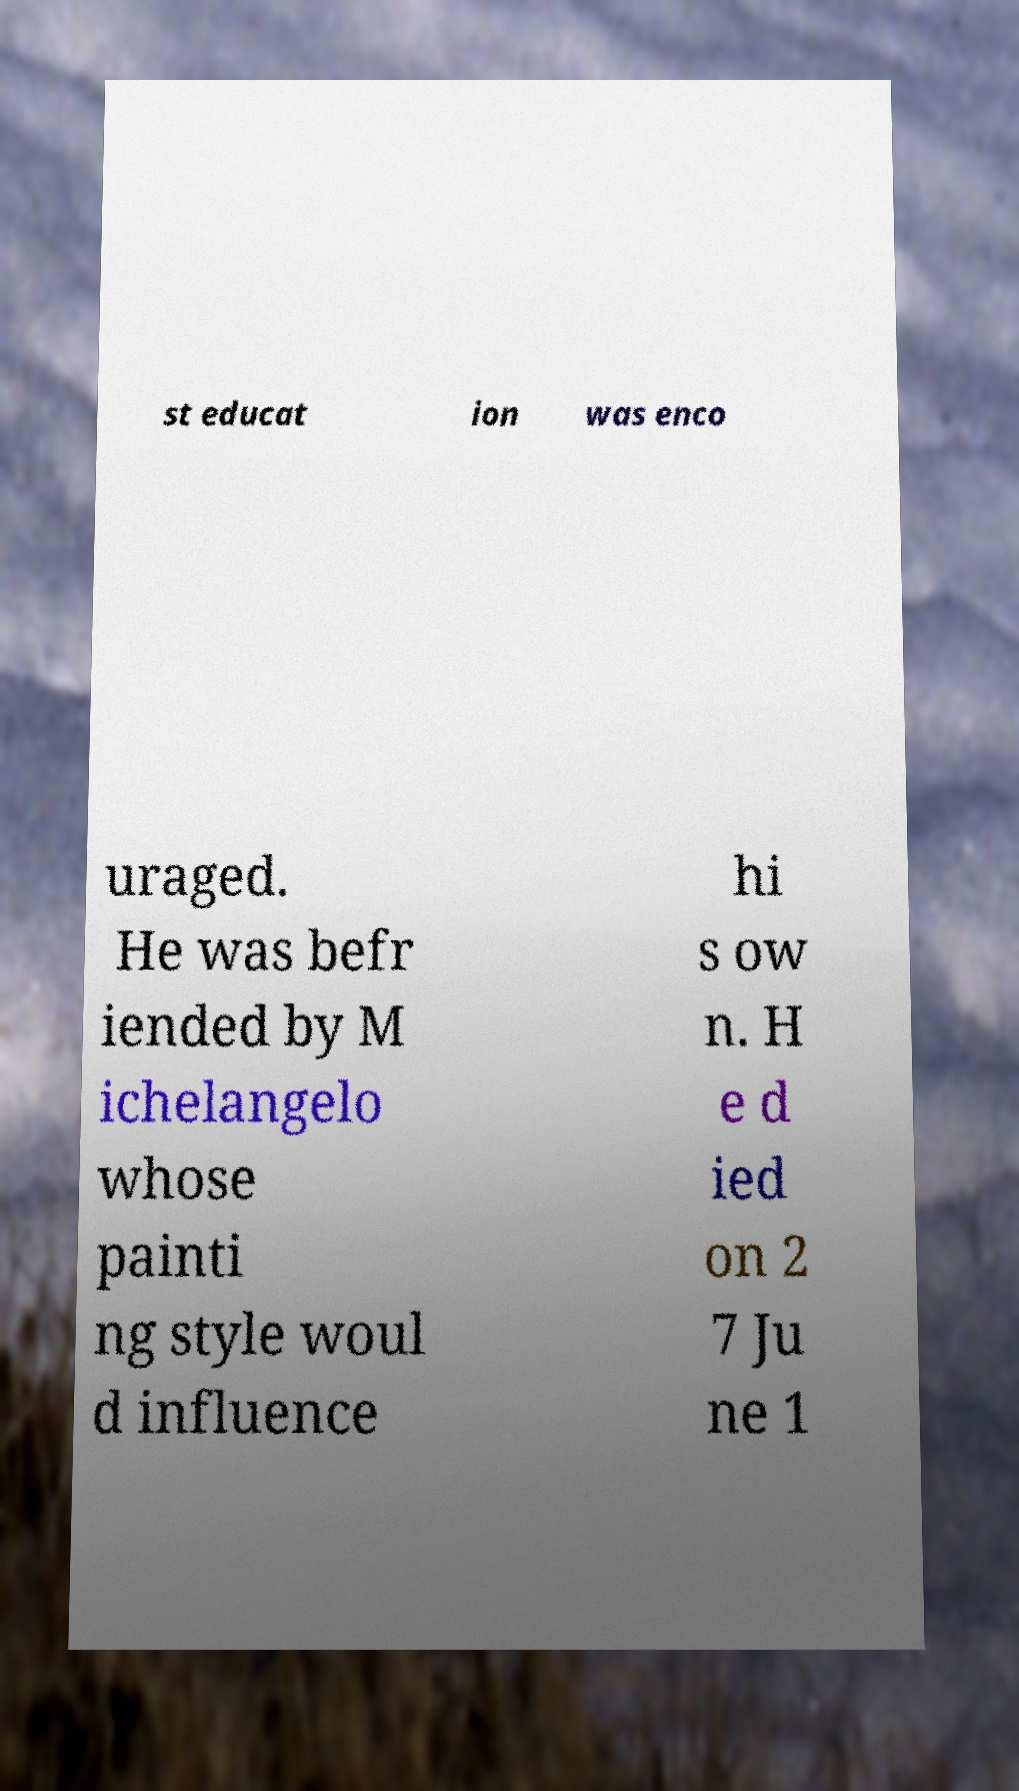For documentation purposes, I need the text within this image transcribed. Could you provide that? st educat ion was enco uraged. He was befr iended by M ichelangelo whose painti ng style woul d influence hi s ow n. H e d ied on 2 7 Ju ne 1 